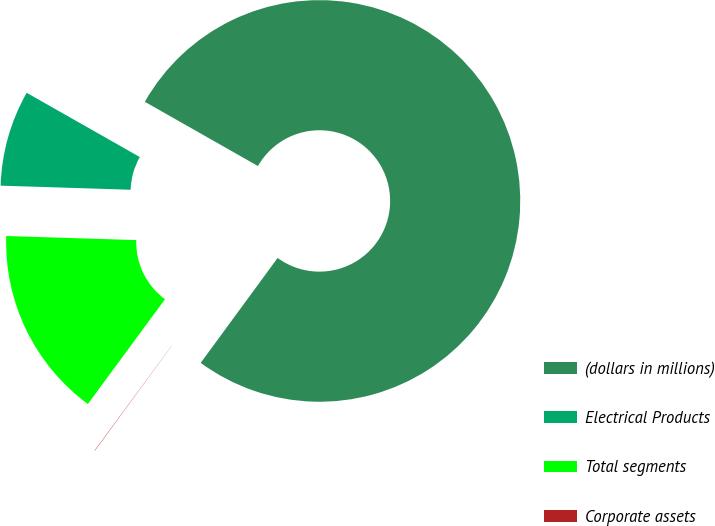<chart> <loc_0><loc_0><loc_500><loc_500><pie_chart><fcel>(dollars in millions)<fcel>Electrical Products<fcel>Total segments<fcel>Corporate assets<nl><fcel>76.85%<fcel>7.72%<fcel>15.4%<fcel>0.03%<nl></chart> 